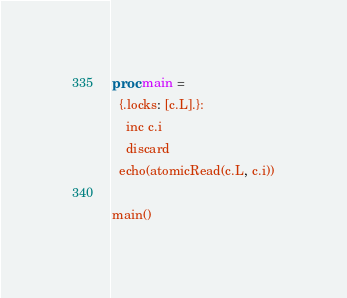<code> <loc_0><loc_0><loc_500><loc_500><_Nim_>
proc main =
  {.locks: [c.L].}:
    inc c.i
    discard
  echo(atomicRead(c.L, c.i))

main()
</code> 